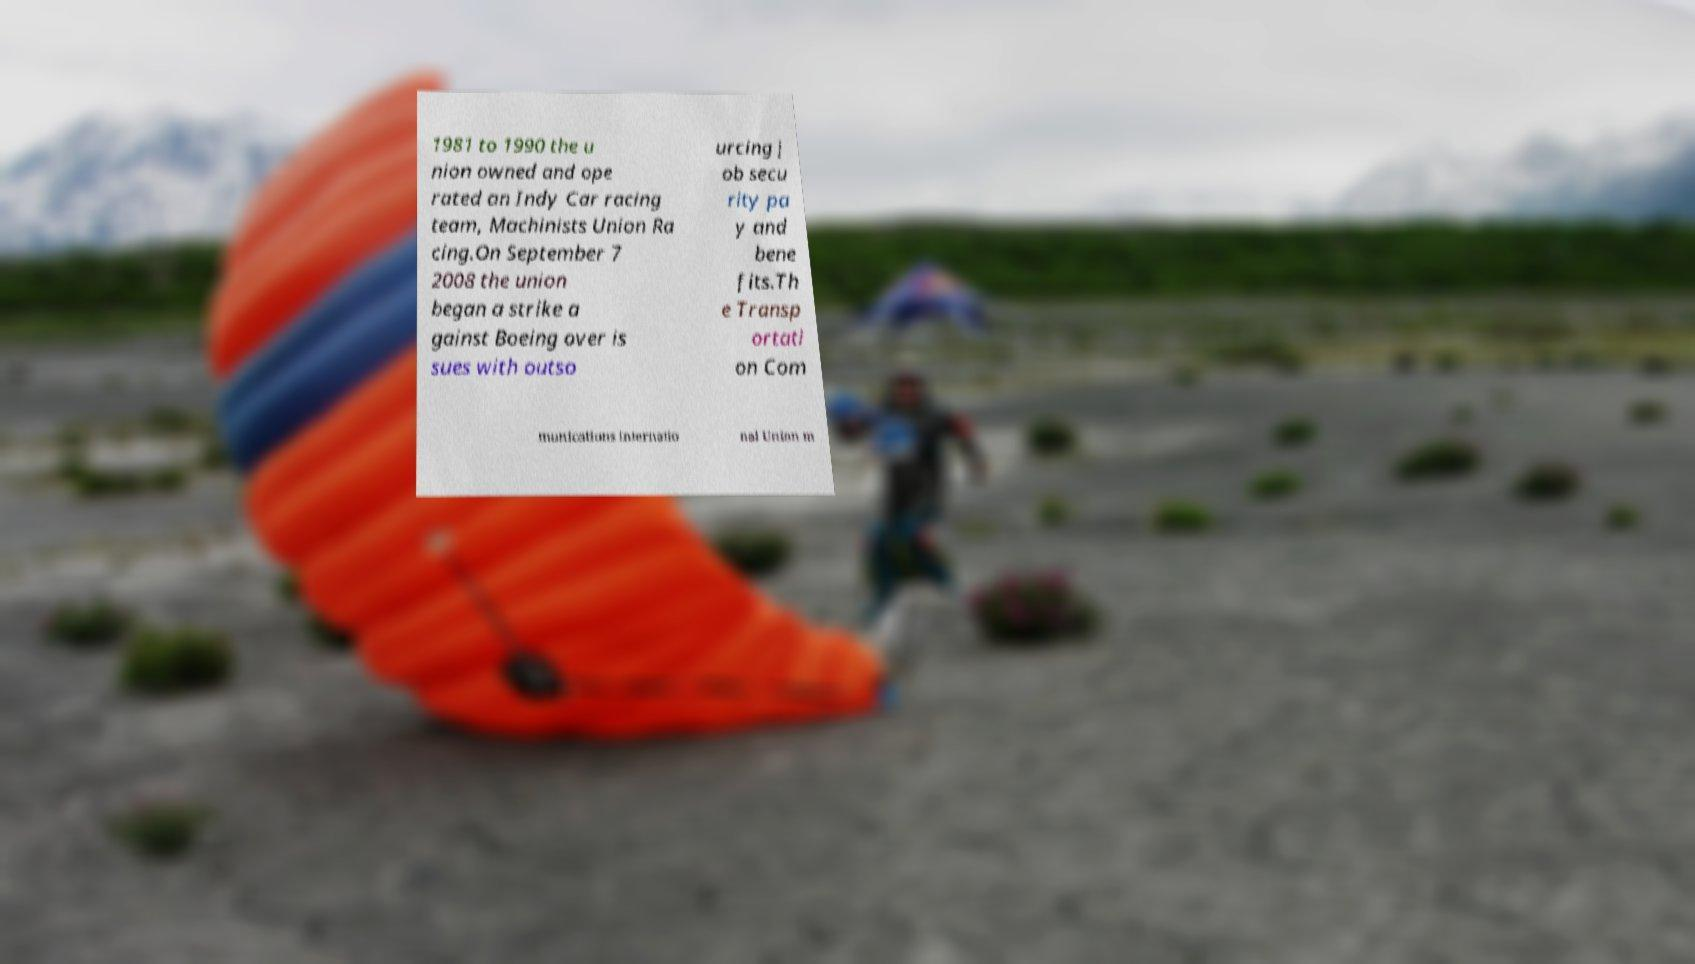Could you assist in decoding the text presented in this image and type it out clearly? 1981 to 1990 the u nion owned and ope rated an Indy Car racing team, Machinists Union Ra cing.On September 7 2008 the union began a strike a gainst Boeing over is sues with outso urcing j ob secu rity pa y and bene fits.Th e Transp ortati on Com munications Internatio nal Union m 